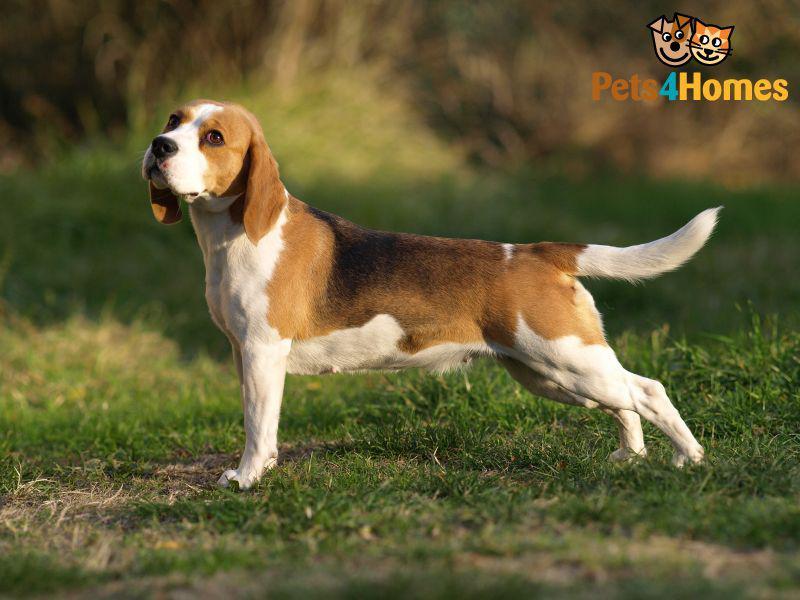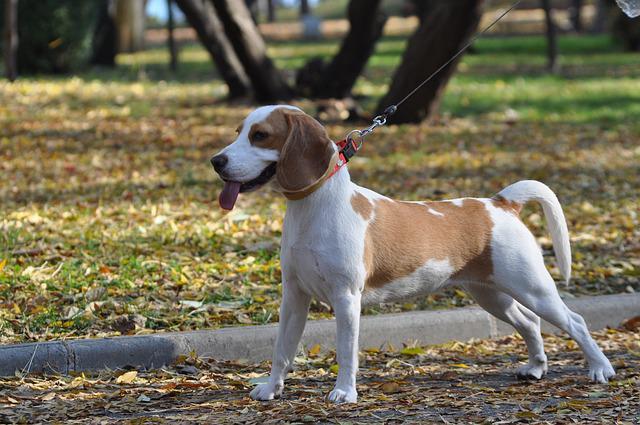The first image is the image on the left, the second image is the image on the right. For the images displayed, is the sentence "The dog in the right image is on a leash." factually correct? Answer yes or no. Yes. 